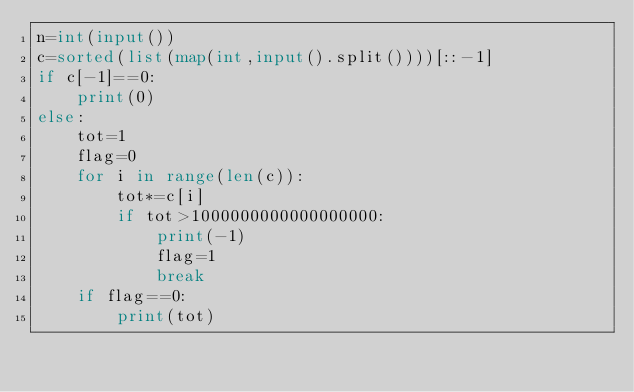Convert code to text. <code><loc_0><loc_0><loc_500><loc_500><_Python_>n=int(input())
c=sorted(list(map(int,input().split())))[::-1]
if c[-1]==0:
	print(0)
else:
	tot=1
	flag=0
	for i in range(len(c)):
		tot*=c[i]
		if tot>1000000000000000000:
			print(-1)
			flag=1
			break
	if flag==0:
		print(tot)
				
</code> 